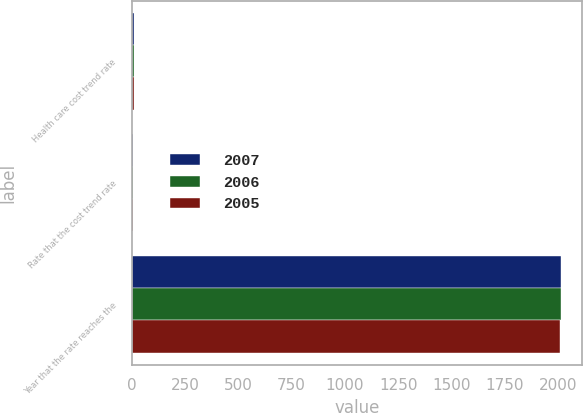Convert chart to OTSL. <chart><loc_0><loc_0><loc_500><loc_500><stacked_bar_chart><ecel><fcel>Health care cost trend rate<fcel>Rate that the cost trend rate<fcel>Year that the rate reaches the<nl><fcel>2007<fcel>10<fcel>5<fcel>2012<nl><fcel>2006<fcel>10<fcel>5<fcel>2011<nl><fcel>2005<fcel>10<fcel>5<fcel>2010<nl></chart> 